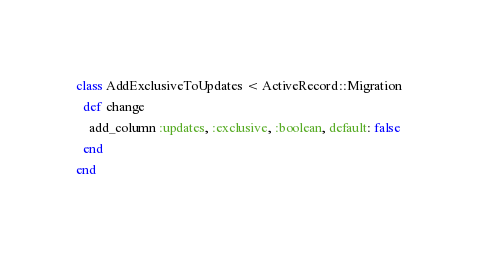<code> <loc_0><loc_0><loc_500><loc_500><_Ruby_>class AddExclusiveToUpdates < ActiveRecord::Migration
  def change
    add_column :updates, :exclusive, :boolean, default: false
  end
end
</code> 